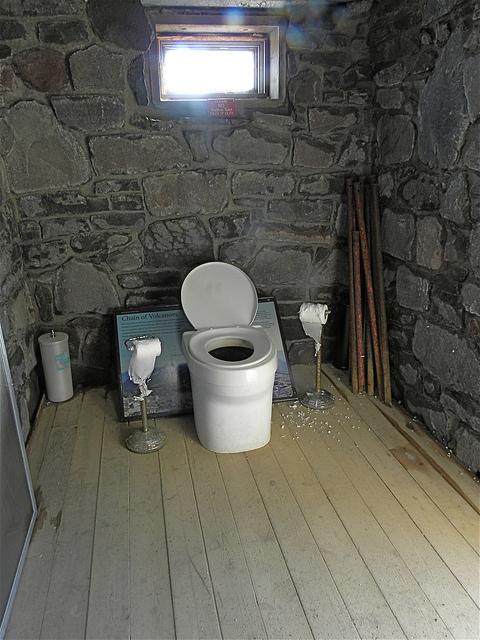Which room is this in the house?
Be succinct. Bathroom. What is a toilet used for?
Answer briefly. To urinate or poop. Is there light coming for inside of the toilet?
Answer briefly. No. What color is the ceiling tile?
Short answer required. Gray. How many toilet paper stand in the room?
Short answer required. 2. 